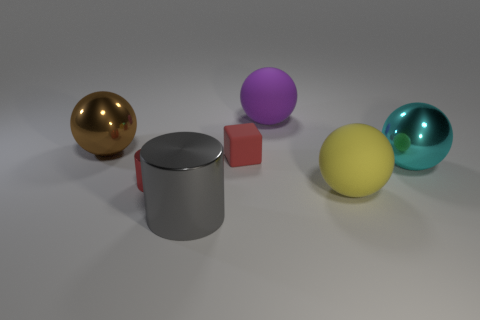Is the gray metal cylinder the same size as the red shiny cylinder?
Your response must be concise. No. Are there any small things of the same color as the small cube?
Your answer should be very brief. Yes. Does the large shiny object left of the big gray shiny thing have the same shape as the cyan shiny thing?
Your answer should be very brief. Yes. How many brown metallic objects have the same size as the matte block?
Your answer should be compact. 0. How many big cyan objects are behind the sphere in front of the red metallic cylinder?
Offer a terse response. 1. Is the tiny thing that is behind the small red metallic cylinder made of the same material as the cyan object?
Give a very brief answer. No. Does the small red object that is behind the large cyan thing have the same material as the large ball that is in front of the tiny red metallic object?
Make the answer very short. Yes. Are there more large balls that are right of the yellow sphere than large red metal spheres?
Offer a terse response. Yes. There is a shiny cylinder that is in front of the tiny red object that is in front of the large cyan metal ball; what is its color?
Your answer should be compact. Gray. There is a cyan thing that is the same size as the purple rubber thing; what is its shape?
Make the answer very short. Sphere. 